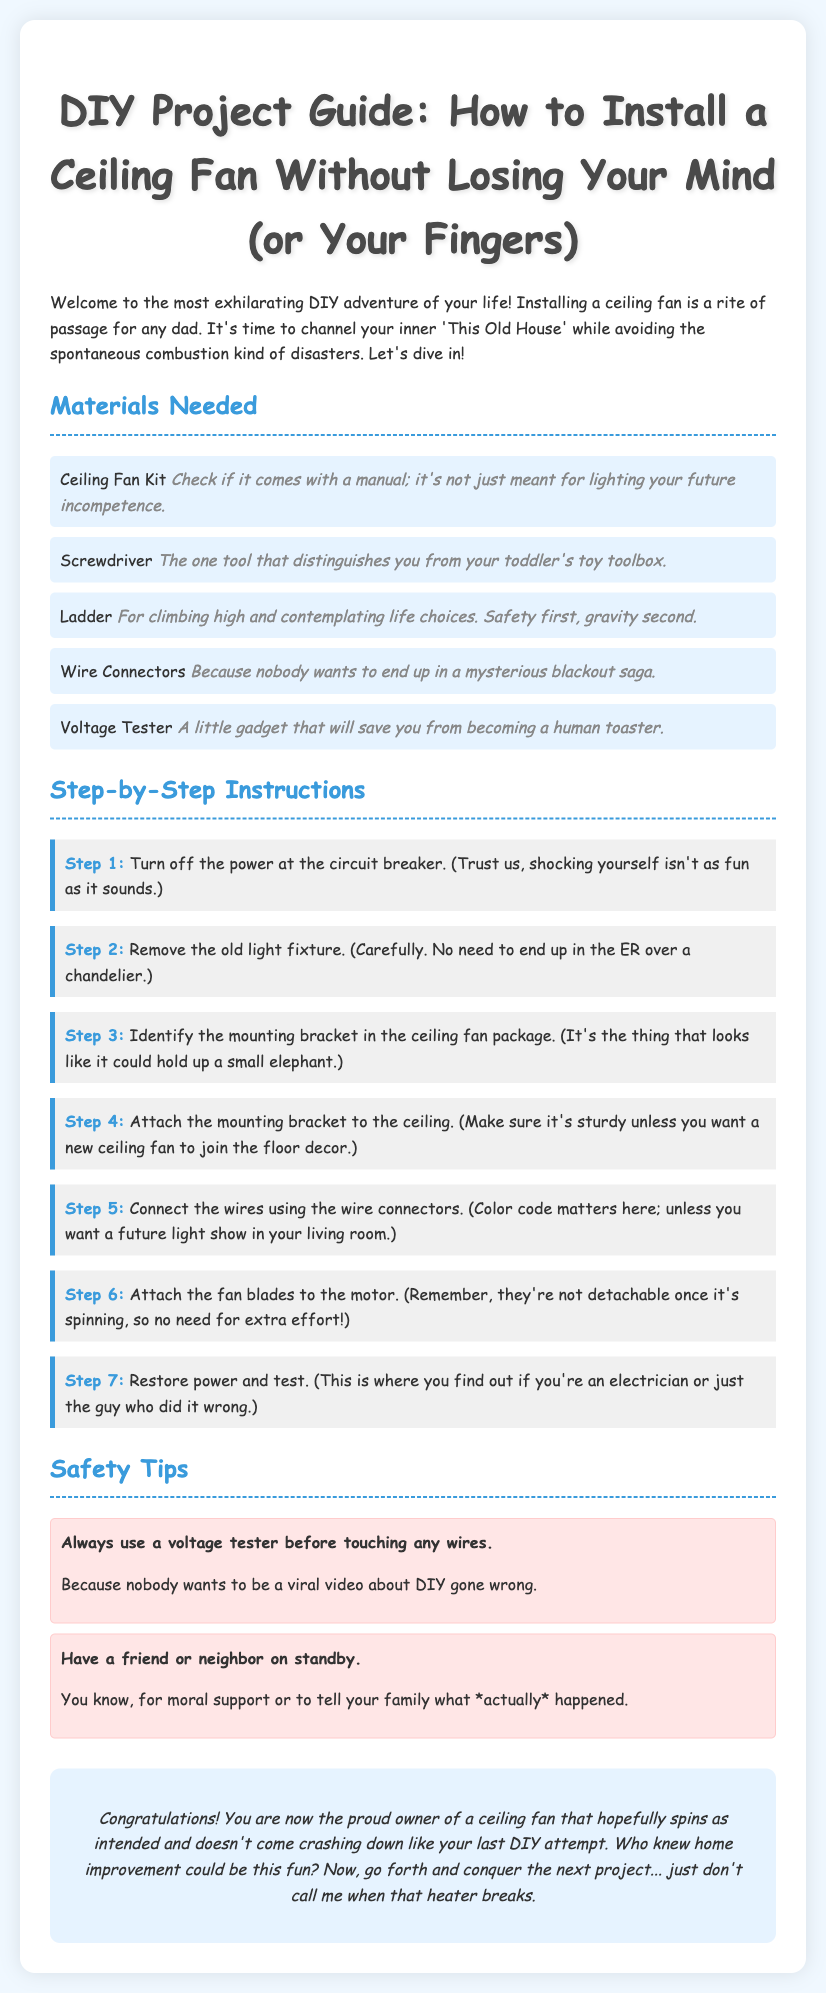what is the title of the document? The title is indicated in the main header of the document, which is "DIY Project Guide: How to Install a Ceiling Fan Without Losing Your Mind (or Your Fingers)."
Answer: DIY Project Guide: How to Install a Ceiling Fan Without Losing Your Mind (or Your Fingers) how many steps are there in the installation instructions? The step-by-step section lists a total of 7 distinct steps for the installation process.
Answer: 7 what tool helps distinguish you from a toddler? The document humorously states that the screwdriver is the tool distinguishing an adult from a child's toy toolbox.
Answer: Screwdriver what is the voltage tester used for? The voltage tester is mentioned as a gadget that helps avoid becoming a human toaster by testing if wires are live.
Answer: A human toaster which step involves connecting the wires? Step 5 clearly describes the action of connecting the wires using wire connectors, indicating the importance of color coding.
Answer: Step 5 what phrase indicates the importance of testing the installation? The phrase mentions restoring power and testing as the moment to find out if you are an electrician or someone who did it wrong.
Answer: Find out if you're an electrician or just the guy who did it wrong what should you have on standby during installation? The document suggests having a friend or neighbor on standby for support during the installation process.
Answer: A friend or neighbor what type of tips are included in the document? The document includes safety tips to ensure a safe DIY experience while installing the ceiling fan.
Answer: Safety tips 